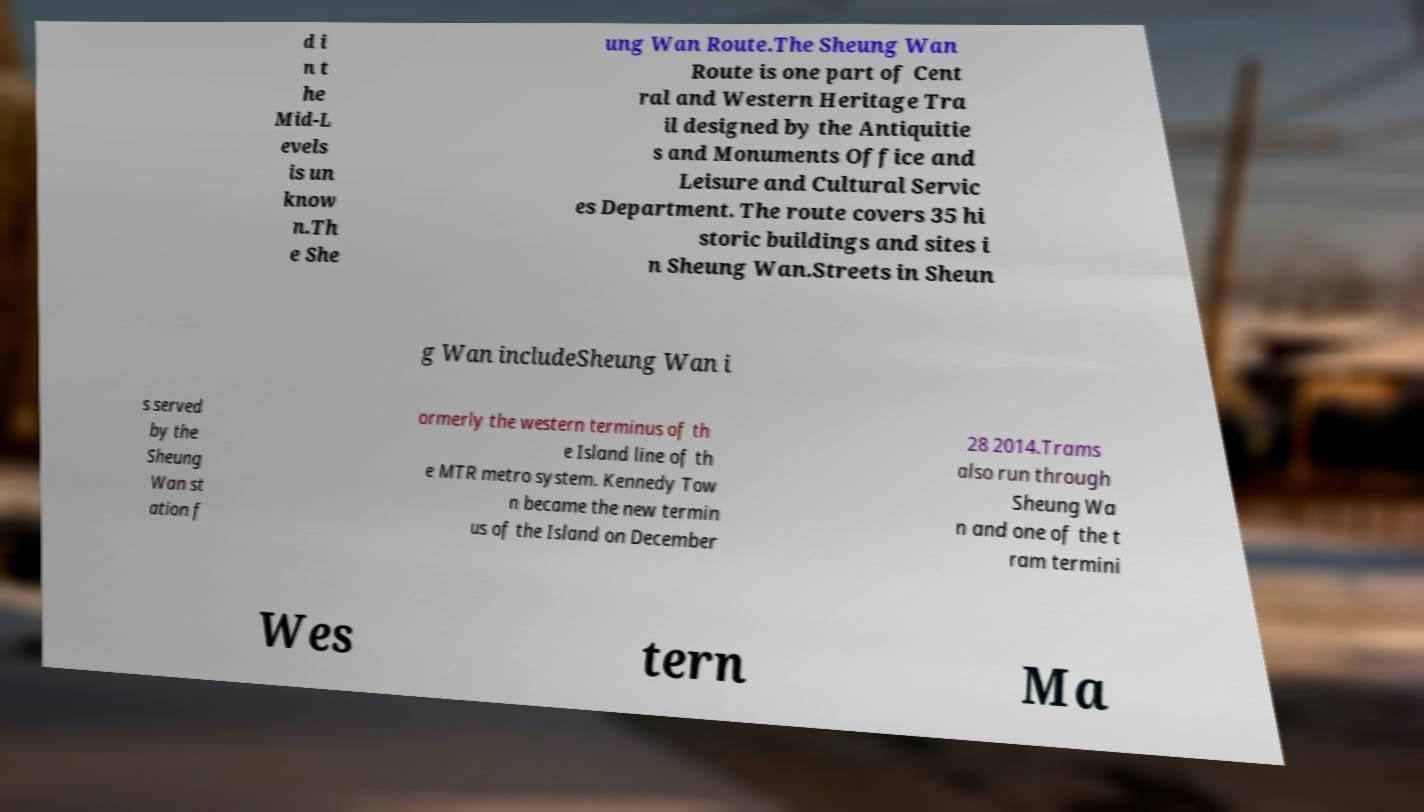Could you extract and type out the text from this image? d i n t he Mid-L evels is un know n.Th e She ung Wan Route.The Sheung Wan Route is one part of Cent ral and Western Heritage Tra il designed by the Antiquitie s and Monuments Office and Leisure and Cultural Servic es Department. The route covers 35 hi storic buildings and sites i n Sheung Wan.Streets in Sheun g Wan includeSheung Wan i s served by the Sheung Wan st ation f ormerly the western terminus of th e Island line of th e MTR metro system. Kennedy Tow n became the new termin us of the Island on December 28 2014.Trams also run through Sheung Wa n and one of the t ram termini Wes tern Ma 